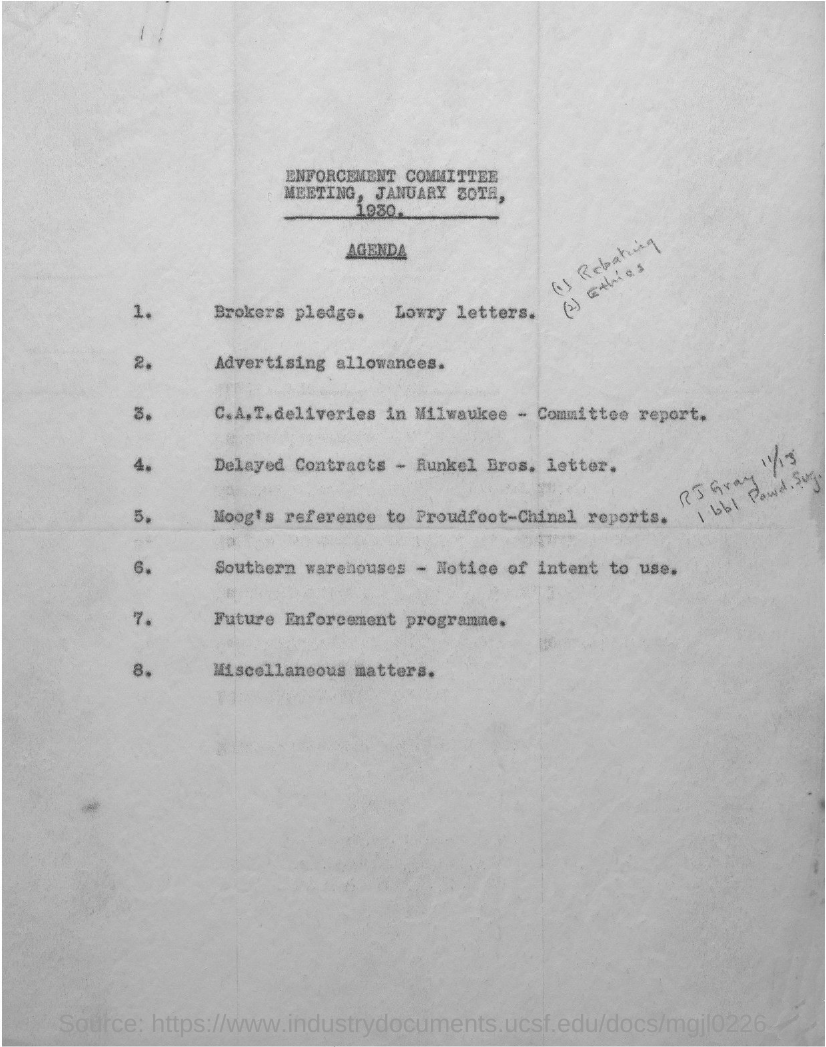Point out several critical features in this image. Agenda item 2 concerns advertising allowances. The agenda item number 8 is related to miscellaneous matters. 